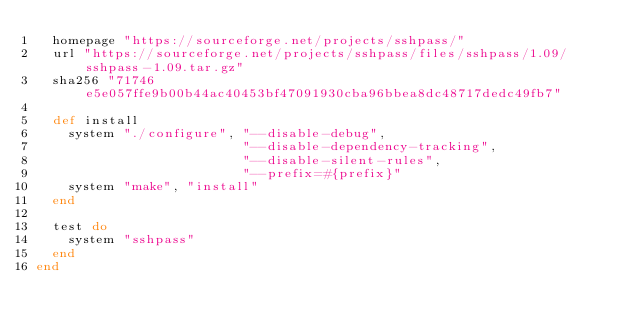<code> <loc_0><loc_0><loc_500><loc_500><_Ruby_>  homepage "https://sourceforge.net/projects/sshpass/"
  url "https://sourceforge.net/projects/sshpass/files/sshpass/1.09/sshpass-1.09.tar.gz"
  sha256 "71746e5e057ffe9b00b44ac40453bf47091930cba96bbea8dc48717dedc49fb7"

  def install
    system "./configure", "--disable-debug",
                          "--disable-dependency-tracking",
                          "--disable-silent-rules",
                          "--prefix=#{prefix}"
    system "make", "install"
  end

  test do
    system "sshpass"
  end
end
</code> 